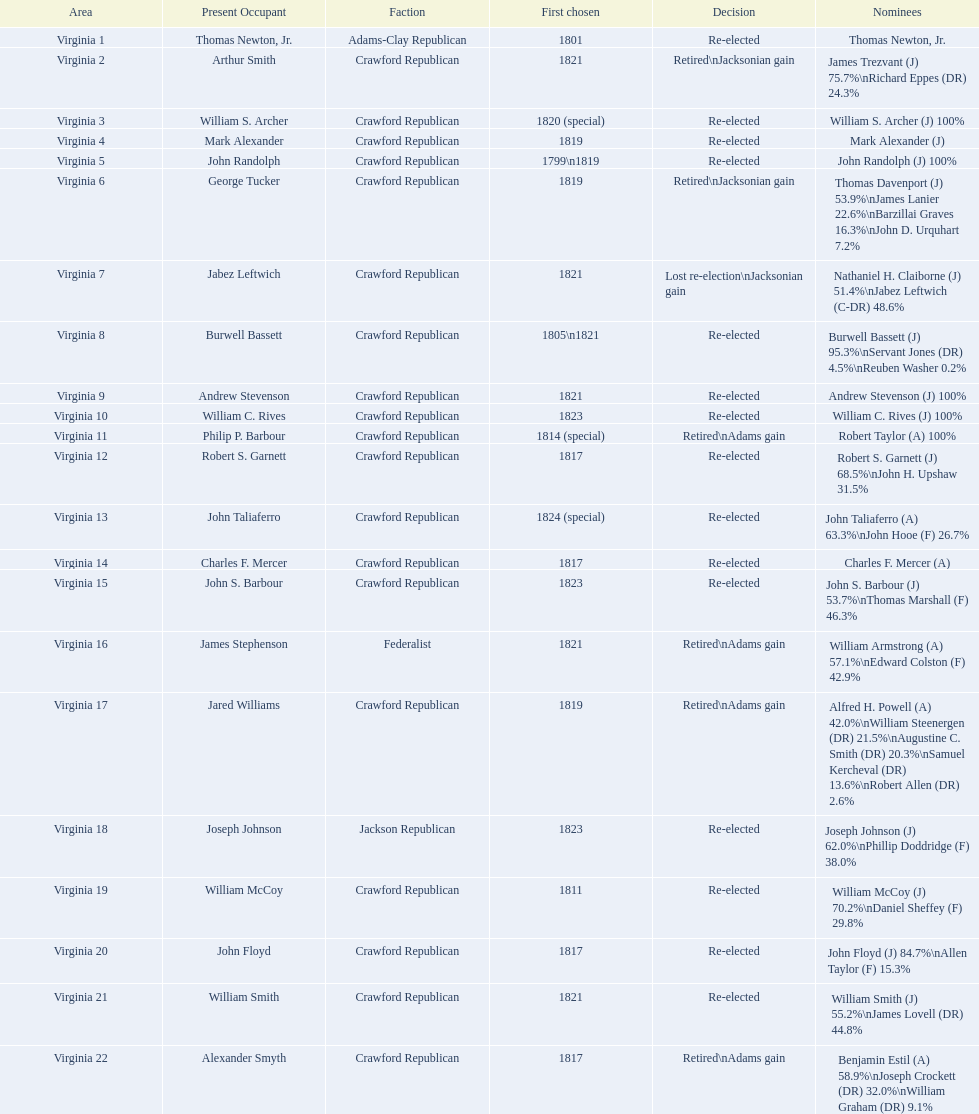Which incumbents belonged to the crawford republican party? Arthur Smith, William S. Archer, Mark Alexander, John Randolph, George Tucker, Jabez Leftwich, Burwell Bassett, Andrew Stevenson, William C. Rives, Philip P. Barbour, Robert S. Garnett, John Taliaferro, Charles F. Mercer, John S. Barbour, Jared Williams, William McCoy, John Floyd, William Smith, Alexander Smyth. Which of these incumbents were first elected in 1821? Arthur Smith, Jabez Leftwich, Andrew Stevenson, William Smith. Which of these incumbents have a last name of smith? Arthur Smith, William Smith. Which of these two were not re-elected? Arthur Smith. 